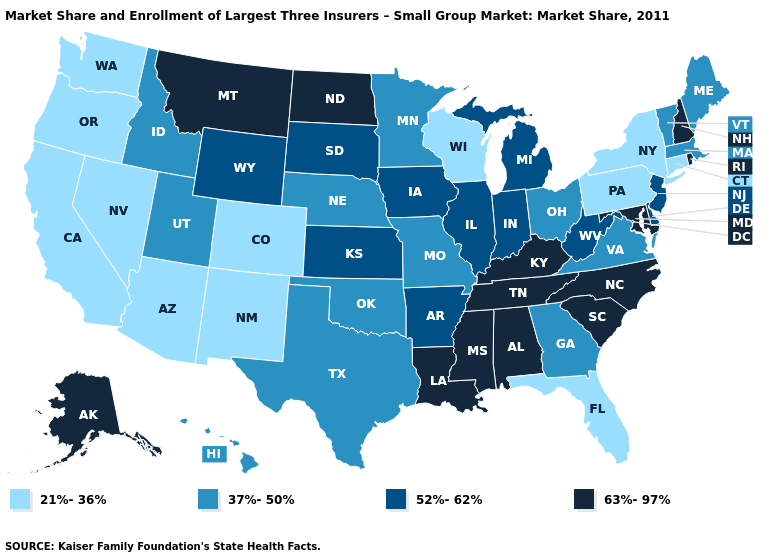What is the value of Mississippi?
Quick response, please. 63%-97%. Name the states that have a value in the range 21%-36%?
Quick response, please. Arizona, California, Colorado, Connecticut, Florida, Nevada, New Mexico, New York, Oregon, Pennsylvania, Washington, Wisconsin. What is the lowest value in states that border New Jersey?
Be succinct. 21%-36%. What is the highest value in the West ?
Be succinct. 63%-97%. What is the value of Missouri?
Keep it brief. 37%-50%. Name the states that have a value in the range 52%-62%?
Write a very short answer. Arkansas, Delaware, Illinois, Indiana, Iowa, Kansas, Michigan, New Jersey, South Dakota, West Virginia, Wyoming. Does Oregon have the lowest value in the USA?
Be succinct. Yes. Does Pennsylvania have the lowest value in the Northeast?
Be succinct. Yes. Does Hawaii have a lower value than Wyoming?
Answer briefly. Yes. What is the lowest value in states that border Kentucky?
Answer briefly. 37%-50%. What is the value of West Virginia?
Be succinct. 52%-62%. What is the value of Kentucky?
Be succinct. 63%-97%. How many symbols are there in the legend?
Give a very brief answer. 4. Among the states that border Indiana , which have the highest value?
Keep it brief. Kentucky. 